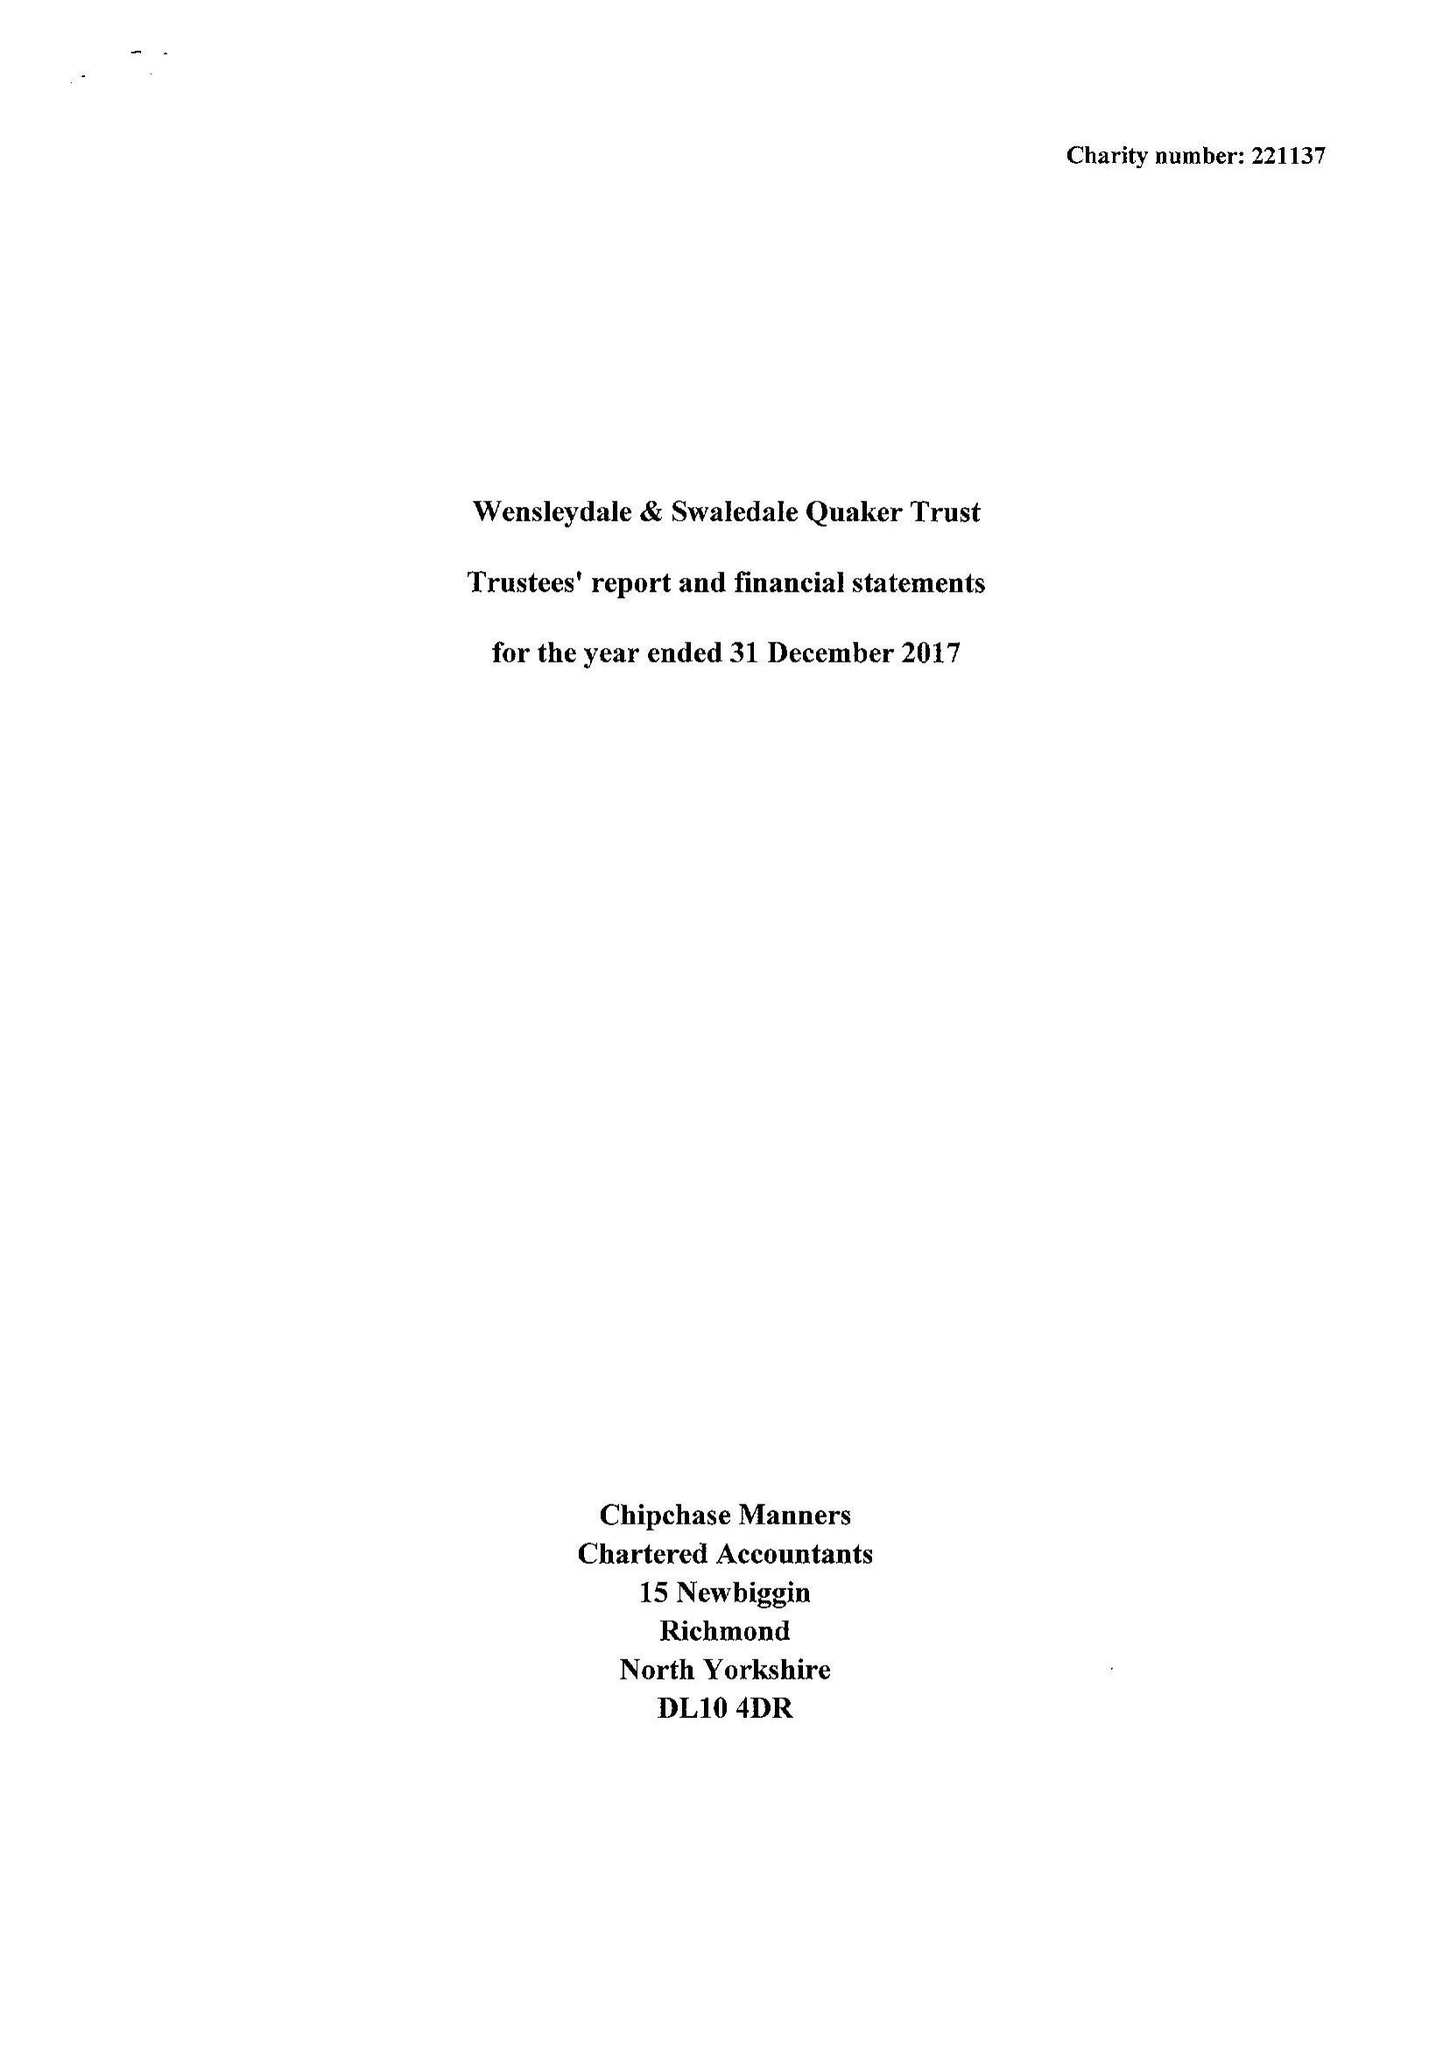What is the value for the address__postcode?
Answer the question using a single word or phrase. DL8 5AE 